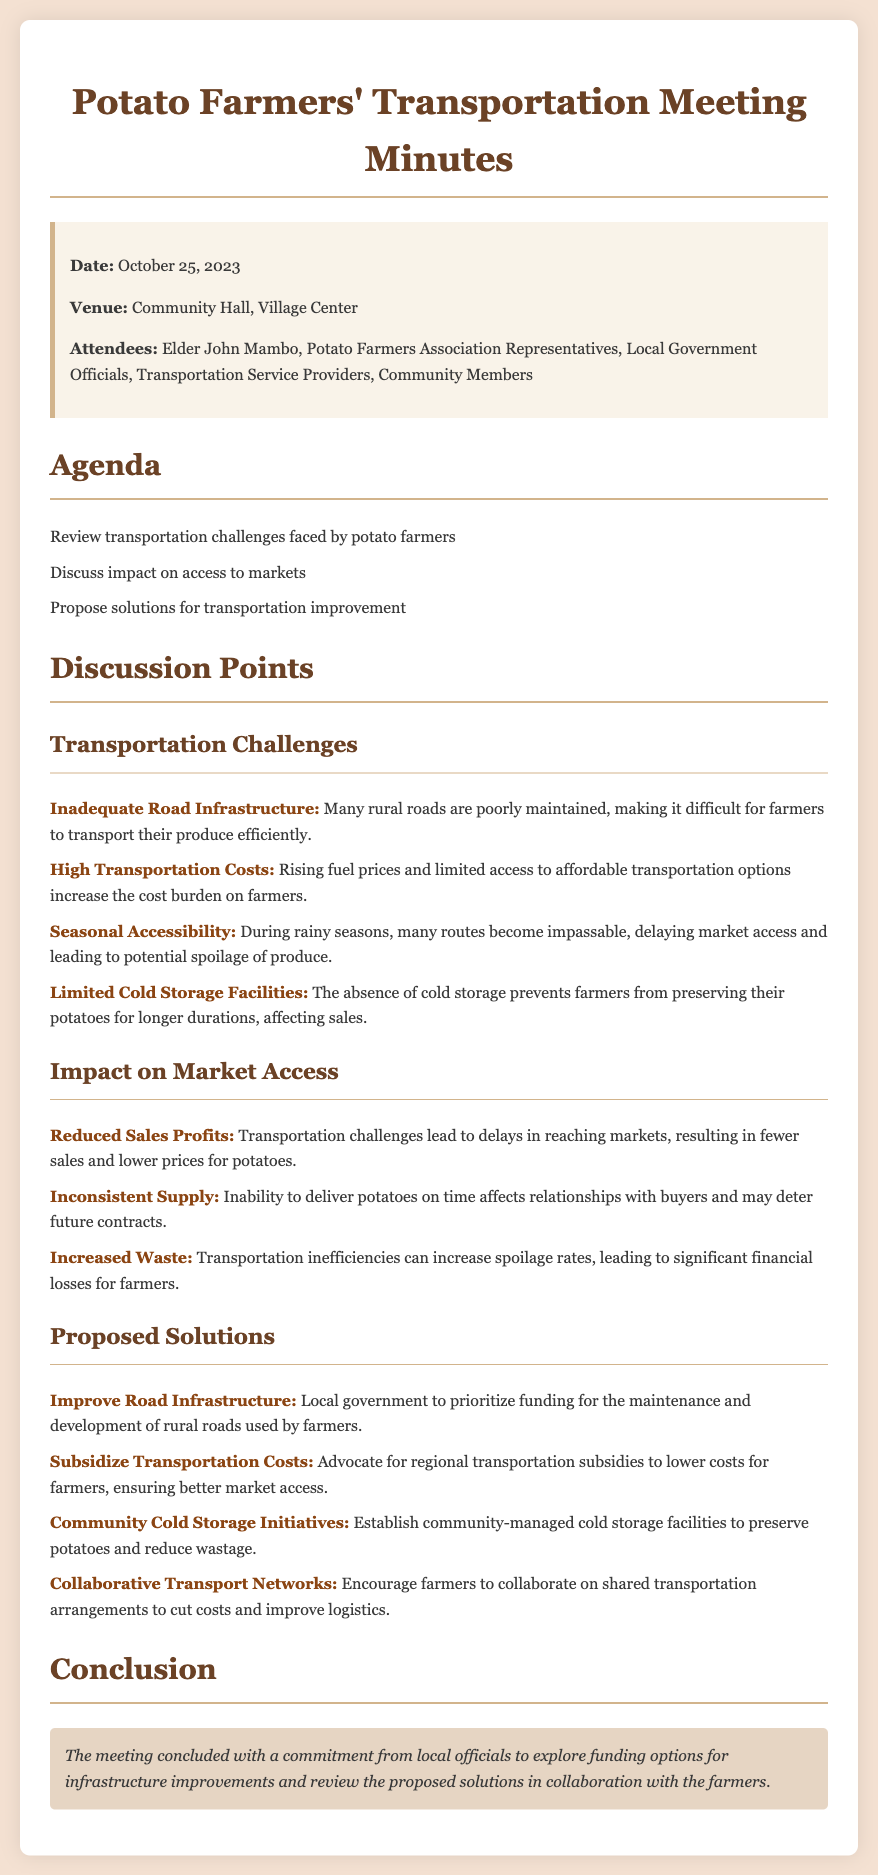What is the date of the meeting? The date of the meeting is mentioned at the beginning of the document.
Answer: October 25, 2023 Who was present at the meeting? The attendees section lists the people present at the meeting, including the elder and representatives.
Answer: Elder John Mambo, Potato Farmers Association Representatives, Local Government Officials, Transportation Service Providers, Community Members What is the main transportation challenge discussed? The discussion points outline several specific challenges faced by potato farmers, highlighting one notable issue.
Answer: Inadequate Road Infrastructure What proposed solution focuses on cost reduction? The document highlights various solutions proposed by the attendees, one specifically addressing the cost issue.
Answer: Subsidize Transportation Costs What is the venue of the meeting? The venue is specified in the information box at the top of the document.
Answer: Community Hall, Village Center How many challenges are listed in the meeting? The discussion points mention several challenges faced by the farmers in accessing markets.
Answer: Four What increase in financial loss is attributed to inefficiencies? This point can be found under the impact on market access, summarizing the effect on finances.
Answer: Increased Waste What did local officials commit to exploring? The conclusion summarizes the commitments made by local officials during the meeting.
Answer: Funding options for infrastructure improvements 